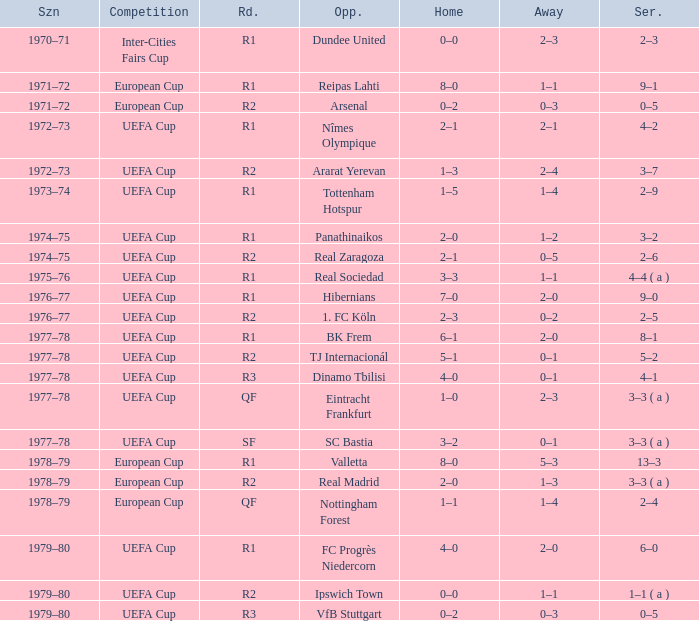Which Series has a Home of 2–0, and an Opponent of panathinaikos? 3–2. 